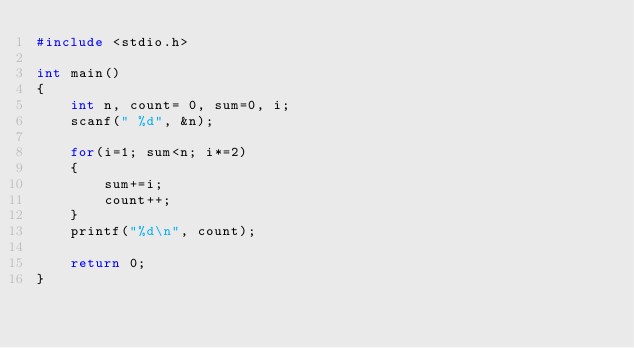Convert code to text. <code><loc_0><loc_0><loc_500><loc_500><_C_>#include <stdio.h>

int main()
{
    int n, count= 0, sum=0, i;
    scanf(" %d", &n);

    for(i=1; sum<n; i*=2)
    {
        sum+=i;
        count++;
    }
    printf("%d\n", count);

    return 0;
}
</code> 